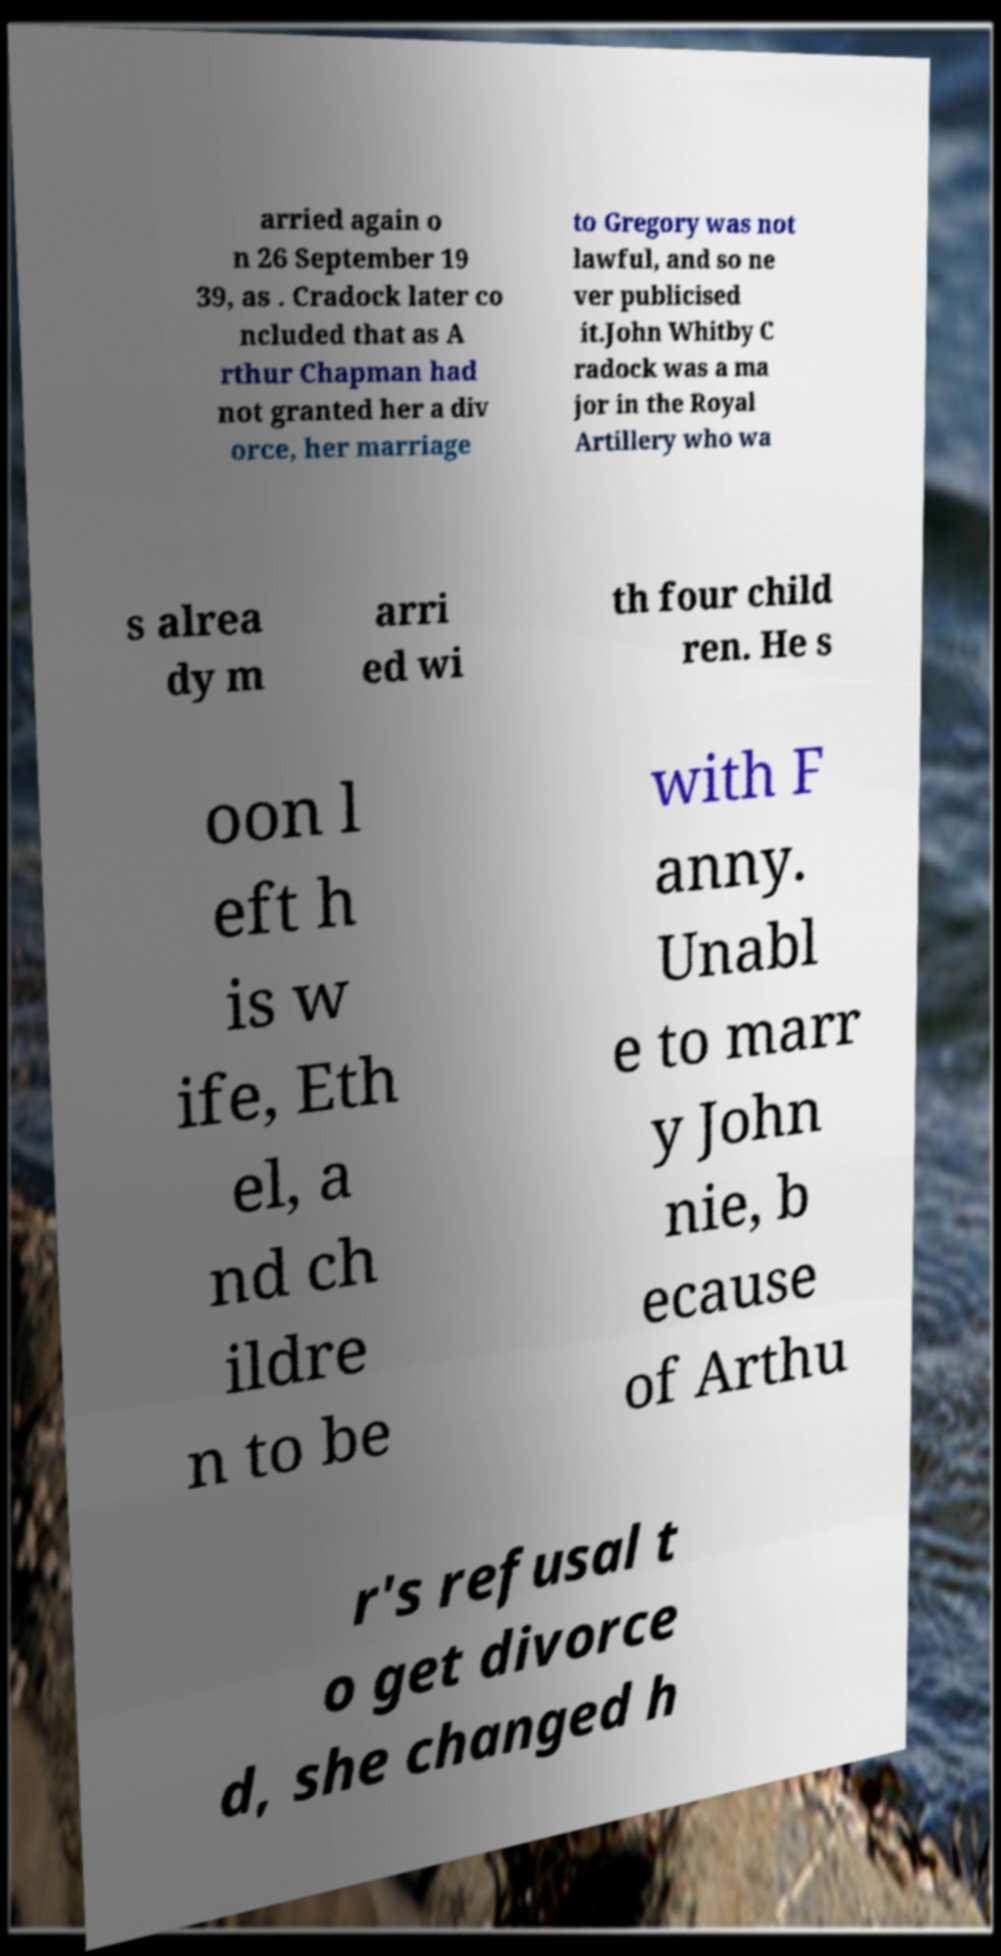I need the written content from this picture converted into text. Can you do that? arried again o n 26 September 19 39, as . Cradock later co ncluded that as A rthur Chapman had not granted her a div orce, her marriage to Gregory was not lawful, and so ne ver publicised it.John Whitby C radock was a ma jor in the Royal Artillery who wa s alrea dy m arri ed wi th four child ren. He s oon l eft h is w ife, Eth el, a nd ch ildre n to be with F anny. Unabl e to marr y John nie, b ecause of Arthu r's refusal t o get divorce d, she changed h 